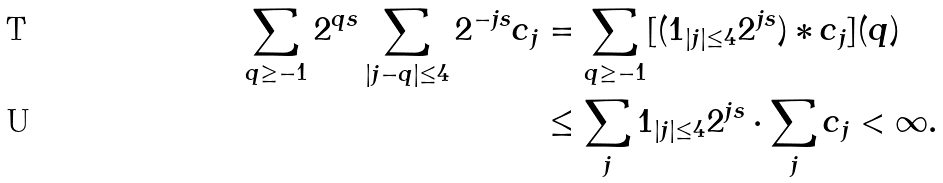<formula> <loc_0><loc_0><loc_500><loc_500>\sum _ { q \geq - 1 } 2 ^ { q s } \sum _ { | j - q | \leq 4 } 2 ^ { - j s } c _ { j } & = \sum _ { q \geq - 1 } [ ( 1 _ { | j | \leq 4 } 2 ^ { j s } ) * c _ { j } ] ( q ) \\ & \leq \sum _ { j } 1 _ { | j | \leq 4 } 2 ^ { j s } \cdot \sum _ { j } c _ { j } < \infty .</formula> 